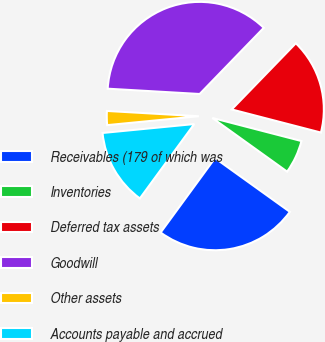<chart> <loc_0><loc_0><loc_500><loc_500><pie_chart><fcel>Receivables (179 of which was<fcel>Inventories<fcel>Deferred tax assets<fcel>Goodwill<fcel>Other assets<fcel>Accounts payable and accrued<nl><fcel>25.14%<fcel>5.87%<fcel>16.79%<fcel>36.33%<fcel>2.46%<fcel>13.41%<nl></chart> 